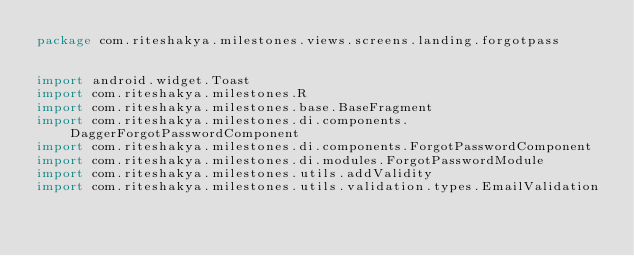Convert code to text. <code><loc_0><loc_0><loc_500><loc_500><_Kotlin_>package com.riteshakya.milestones.views.screens.landing.forgotpass


import android.widget.Toast
import com.riteshakya.milestones.R
import com.riteshakya.milestones.base.BaseFragment
import com.riteshakya.milestones.di.components.DaggerForgotPasswordComponent
import com.riteshakya.milestones.di.components.ForgotPasswordComponent
import com.riteshakya.milestones.di.modules.ForgotPasswordModule
import com.riteshakya.milestones.utils.addValidity
import com.riteshakya.milestones.utils.validation.types.EmailValidation</code> 